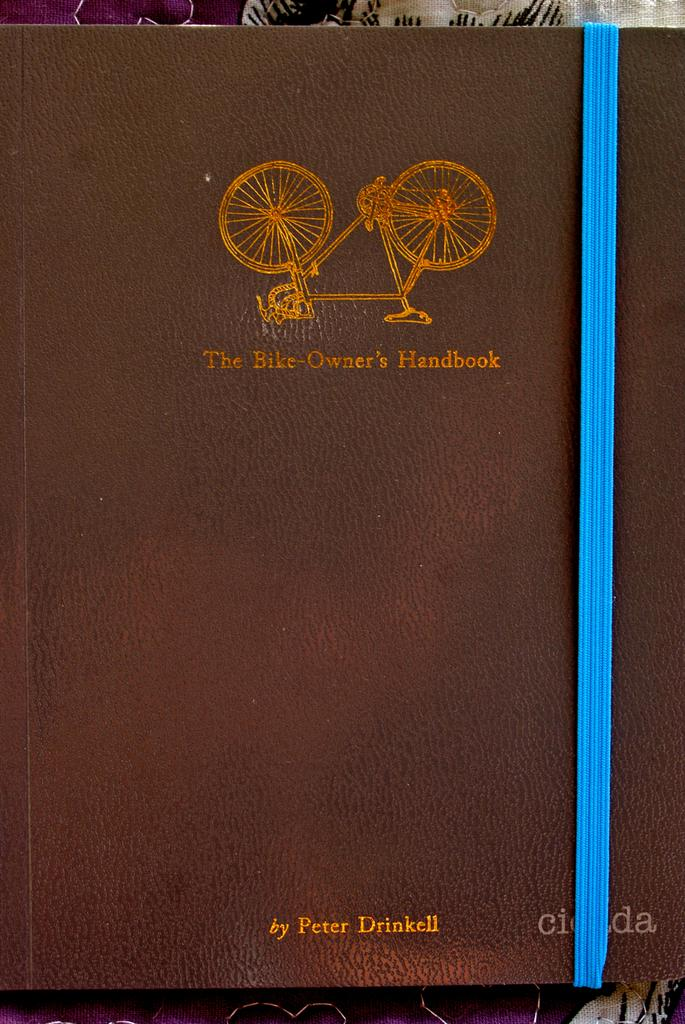<image>
Give a short and clear explanation of the subsequent image. Peter Drinkell's "The Bike-Owner's Handbook" sits on a table. 